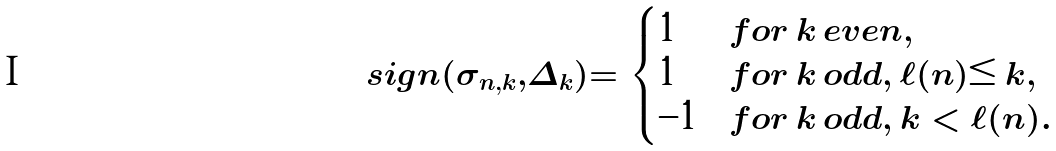Convert formula to latex. <formula><loc_0><loc_0><loc_500><loc_500>s i g n ( \sigma _ { n , k } , \Delta _ { k } ) = \begin{cases} 1 & f o r \, k \, e v e n , \\ 1 & f o r \, k \, o d d , \, \ell ( n ) \leq k , \\ - 1 & f o r \, k \, o d d , \, k < \ell ( n ) . \end{cases}</formula> 